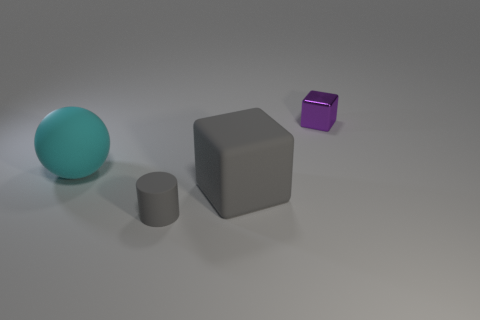What is the size of the thing that is the same color as the big matte block?
Give a very brief answer. Small. Do the rubber block and the cylinder have the same color?
Ensure brevity in your answer.  Yes. The large rubber thing that is the same color as the small rubber thing is what shape?
Make the answer very short. Cube. Is there any other thing that has the same material as the small block?
Ensure brevity in your answer.  No. There is a object that is in front of the big gray cube; is it the same color as the large matte thing right of the small matte cylinder?
Give a very brief answer. Yes. Are there the same number of tiny gray cylinders that are behind the large cyan matte object and large purple matte cylinders?
Offer a very short reply. Yes. What number of things are objects on the right side of the cyan rubber thing or big objects?
Give a very brief answer. 4. There is a object that is both behind the rubber block and left of the small purple metal object; what shape is it?
Provide a short and direct response. Sphere. How many objects are either rubber objects that are behind the large cube or tiny things behind the gray cylinder?
Give a very brief answer. 2. How many other objects are there of the same size as the cyan object?
Your answer should be very brief. 1. 